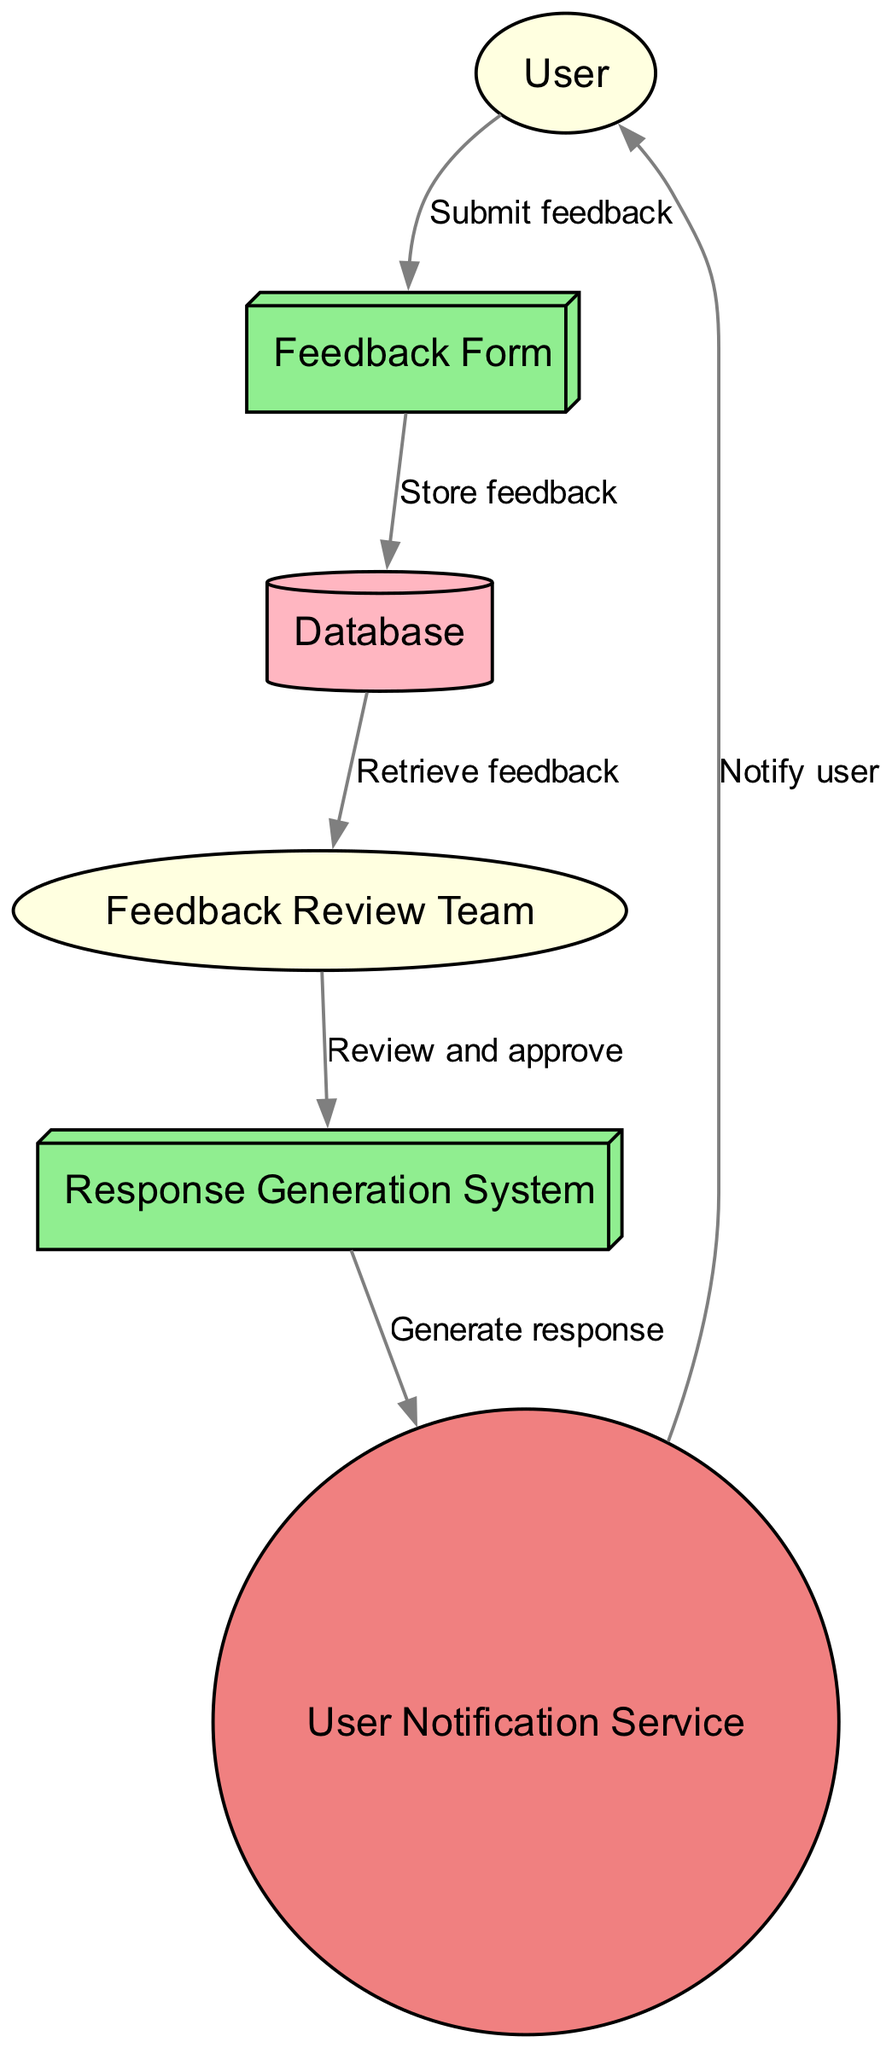What is the first action taken by the User? The User begins the process by submitting their feedback through the Feedback Form, which is indicated as the first edge in the sequence diagram.
Answer: Submit feedback How many components are present in the diagram? The diagram contains three components: Feedback Form, Response Generation System, and User Notification Service, which can be counted directly in the diagram.
Answer: Three Who is responsible for reviewing user feedback? The Feedback Review Team is designated as the actor that retrieves and reviews user feedback from the Database as represented in the diagram sequence.
Answer: Feedback Review Team What does the Response Generation System do? The Response Generation System generates automated responses based on the reviewed feedback, as indicated by the flow between the Feedback Review Team and the User Notification Service.
Answer: Generate response In what order do the elements interact after feedback submission? The sequence is: User submits feedback to Feedback Form, Feedback Form stores feedback in Database, Database is accessed by Feedback Review Team, which then interacts with Response Generation System that generates a response sent to the User Notification Service, ultimately notifying the User.
Answer: User, Feedback Form, Database, Feedback Review Team, Response Generation System, User Notification Service, User What type of element is the Database? The Database is categorized as a Storage element in the diagram, which is represented by a cylinder shape.
Answer: Storage How does the User get notified after submitting feedback? The User is notified through the User Notification Service, which is the final action in the sequence of the diagram after the feedback is processed.
Answer: Notify user What happens after the feedback is stored in the Database? Once the feedback is stored in the Database, it is retrieved by the Feedback Review Team for further action, as shown in the diagram flow.
Answer: Retrieve feedback 